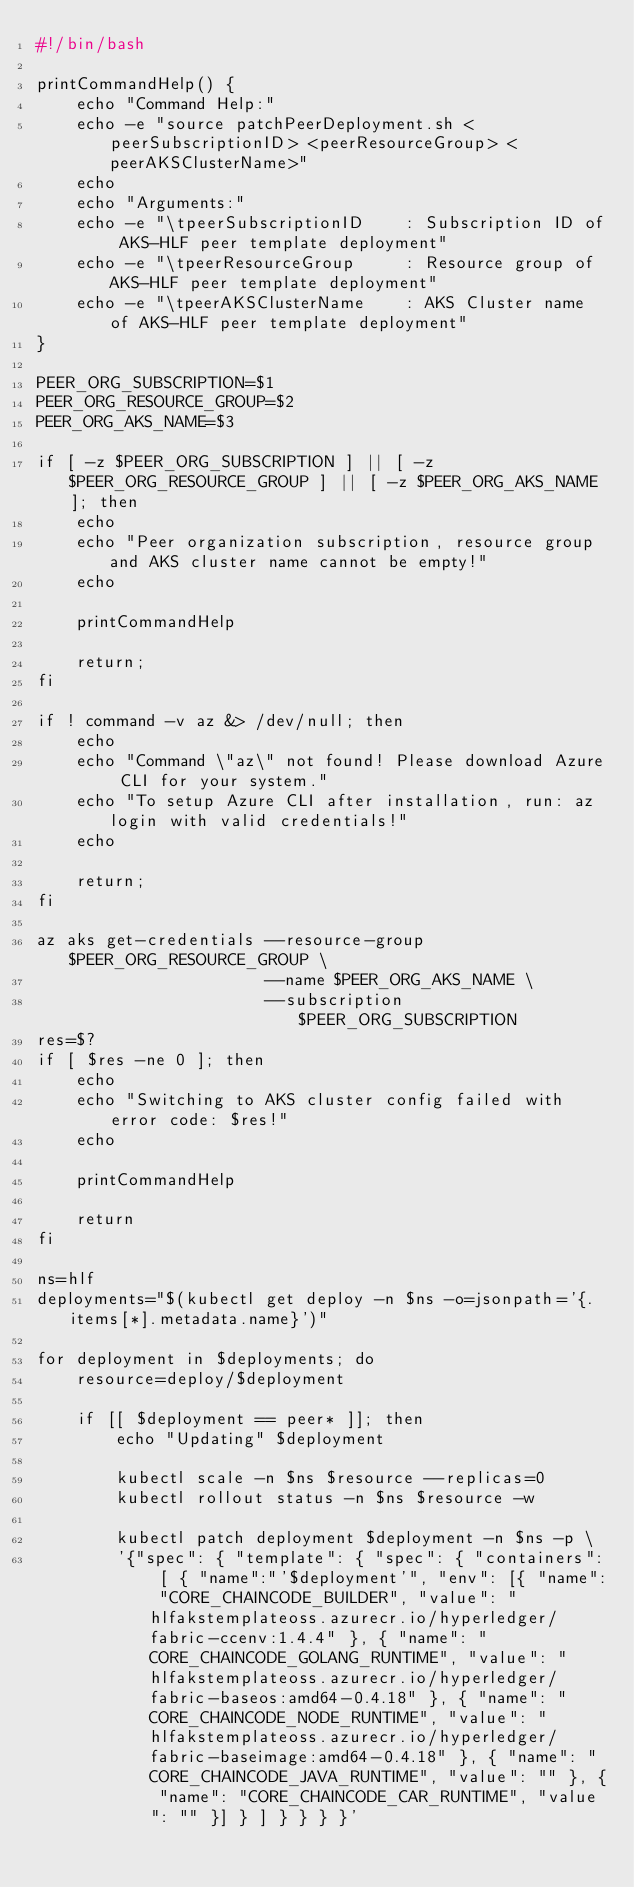<code> <loc_0><loc_0><loc_500><loc_500><_Bash_>#!/bin/bash

printCommandHelp() {
    echo "Command Help:"
    echo -e "source patchPeerDeployment.sh <peerSubscriptionID> <peerResourceGroup> <peerAKSClusterName>"
    echo
    echo "Arguments:"
    echo -e "\tpeerSubscriptionID    : Subscription ID of AKS-HLF peer template deployment"
    echo -e "\tpeerResourceGroup     : Resource group of AKS-HLF peer template deployment"
    echo -e "\tpeerAKSClusterName    : AKS Cluster name of AKS-HLF peer template deployment"
}

PEER_ORG_SUBSCRIPTION=$1
PEER_ORG_RESOURCE_GROUP=$2
PEER_ORG_AKS_NAME=$3

if [ -z $PEER_ORG_SUBSCRIPTION ] || [ -z $PEER_ORG_RESOURCE_GROUP ] || [ -z $PEER_ORG_AKS_NAME ]; then
    echo
    echo "Peer organization subscription, resource group and AKS cluster name cannot be empty!"
    echo

    printCommandHelp

    return;
fi

if ! command -v az &> /dev/null; then
    echo
    echo "Command \"az\" not found! Please download Azure CLI for your system."
    echo "To setup Azure CLI after installation, run: az login with valid credentials!"
    echo

    return;
fi

az aks get-credentials --resource-group $PEER_ORG_RESOURCE_GROUP \
                       --name $PEER_ORG_AKS_NAME \
                       --subscription $PEER_ORG_SUBSCRIPTION
res=$?
if [ $res -ne 0 ]; then
    echo
    echo "Switching to AKS cluster config failed with error code: $res!"
    echo

    printCommandHelp
    
    return
fi

ns=hlf
deployments="$(kubectl get deploy -n $ns -o=jsonpath='{.items[*].metadata.name}')"

for deployment in $deployments; do
    resource=deploy/$deployment

    if [[ $deployment == peer* ]]; then
        echo "Updating" $deployment

        kubectl scale -n $ns $resource --replicas=0
        kubectl rollout status -n $ns $resource -w

        kubectl patch deployment $deployment -n $ns -p \
        '{"spec": { "template": { "spec": { "containers": [ { "name":"'$deployment'", "env": [{ "name": "CORE_CHAINCODE_BUILDER", "value": "hlfakstemplateoss.azurecr.io/hyperledger/fabric-ccenv:1.4.4" }, { "name": "CORE_CHAINCODE_GOLANG_RUNTIME", "value": "hlfakstemplateoss.azurecr.io/hyperledger/fabric-baseos:amd64-0.4.18" }, { "name": "CORE_CHAINCODE_NODE_RUNTIME", "value": "hlfakstemplateoss.azurecr.io/hyperledger/fabric-baseimage:amd64-0.4.18" }, { "name": "CORE_CHAINCODE_JAVA_RUNTIME", "value": "" }, { "name": "CORE_CHAINCODE_CAR_RUNTIME", "value": "" }] } ] } } } }'
</code> 